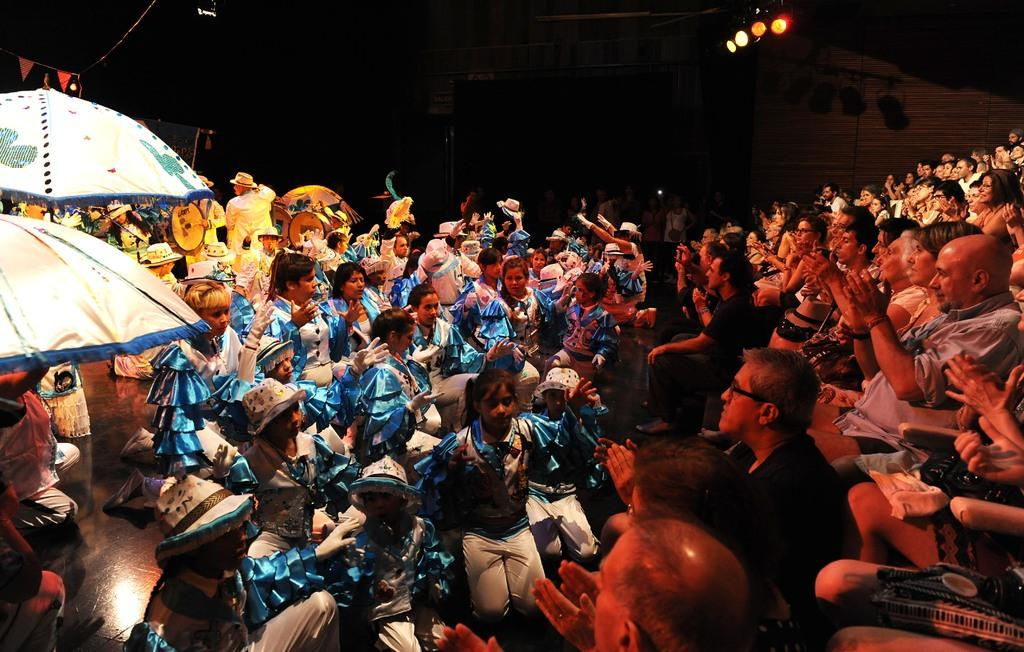What are the people in the image wearing? The persons in the image are wearing clothes. What can be seen on the left side of the image? There are umbrellas on the left side of the image. What is located in the top right of the image? There are lights in the top right of the image. What type of metal is the servant using to carry the bucket in the image? There is no servant or bucket present in the image. 